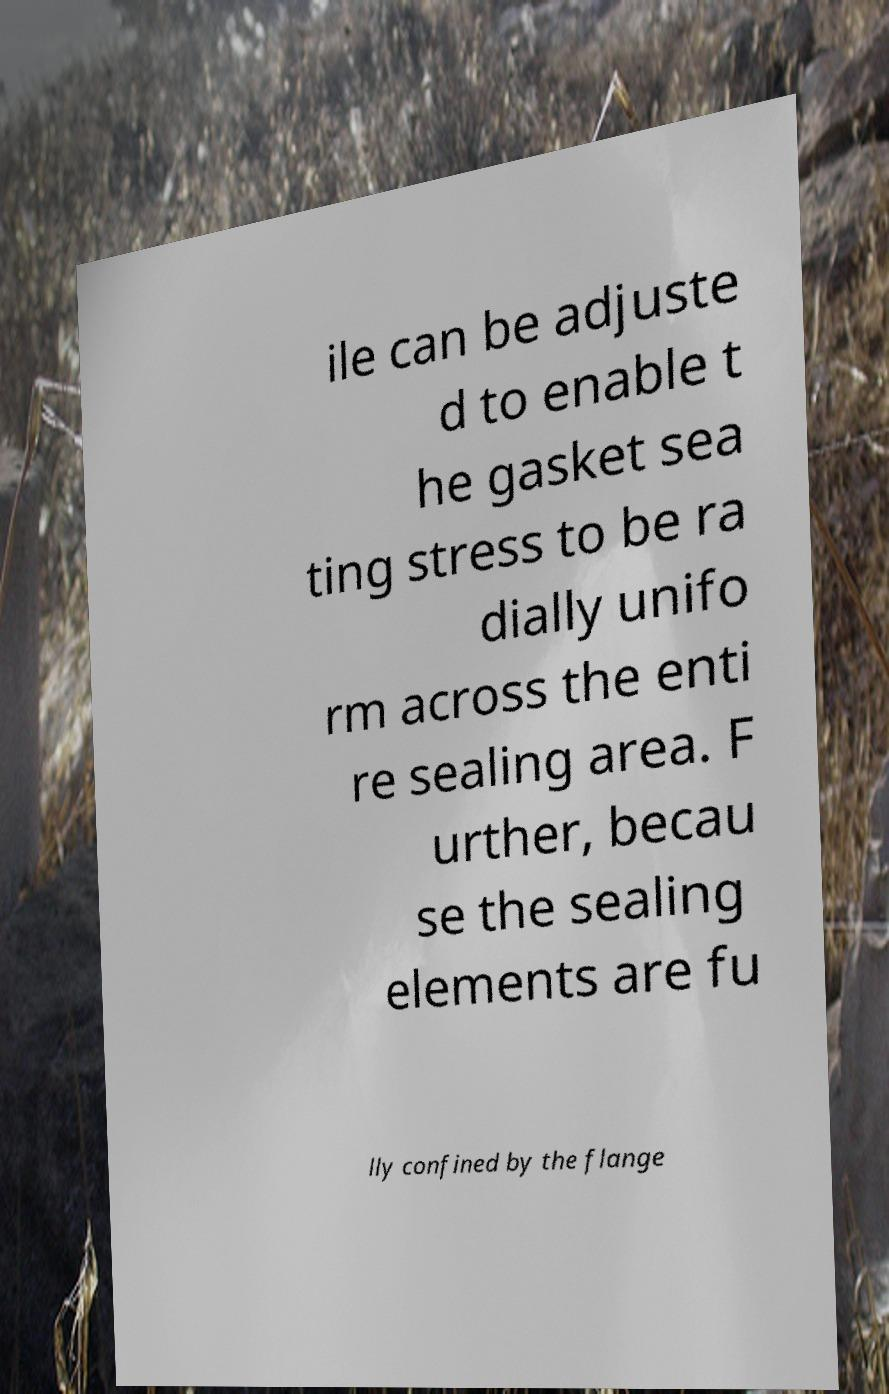Please identify and transcribe the text found in this image. ile can be adjuste d to enable t he gasket sea ting stress to be ra dially unifo rm across the enti re sealing area. F urther, becau se the sealing elements are fu lly confined by the flange 